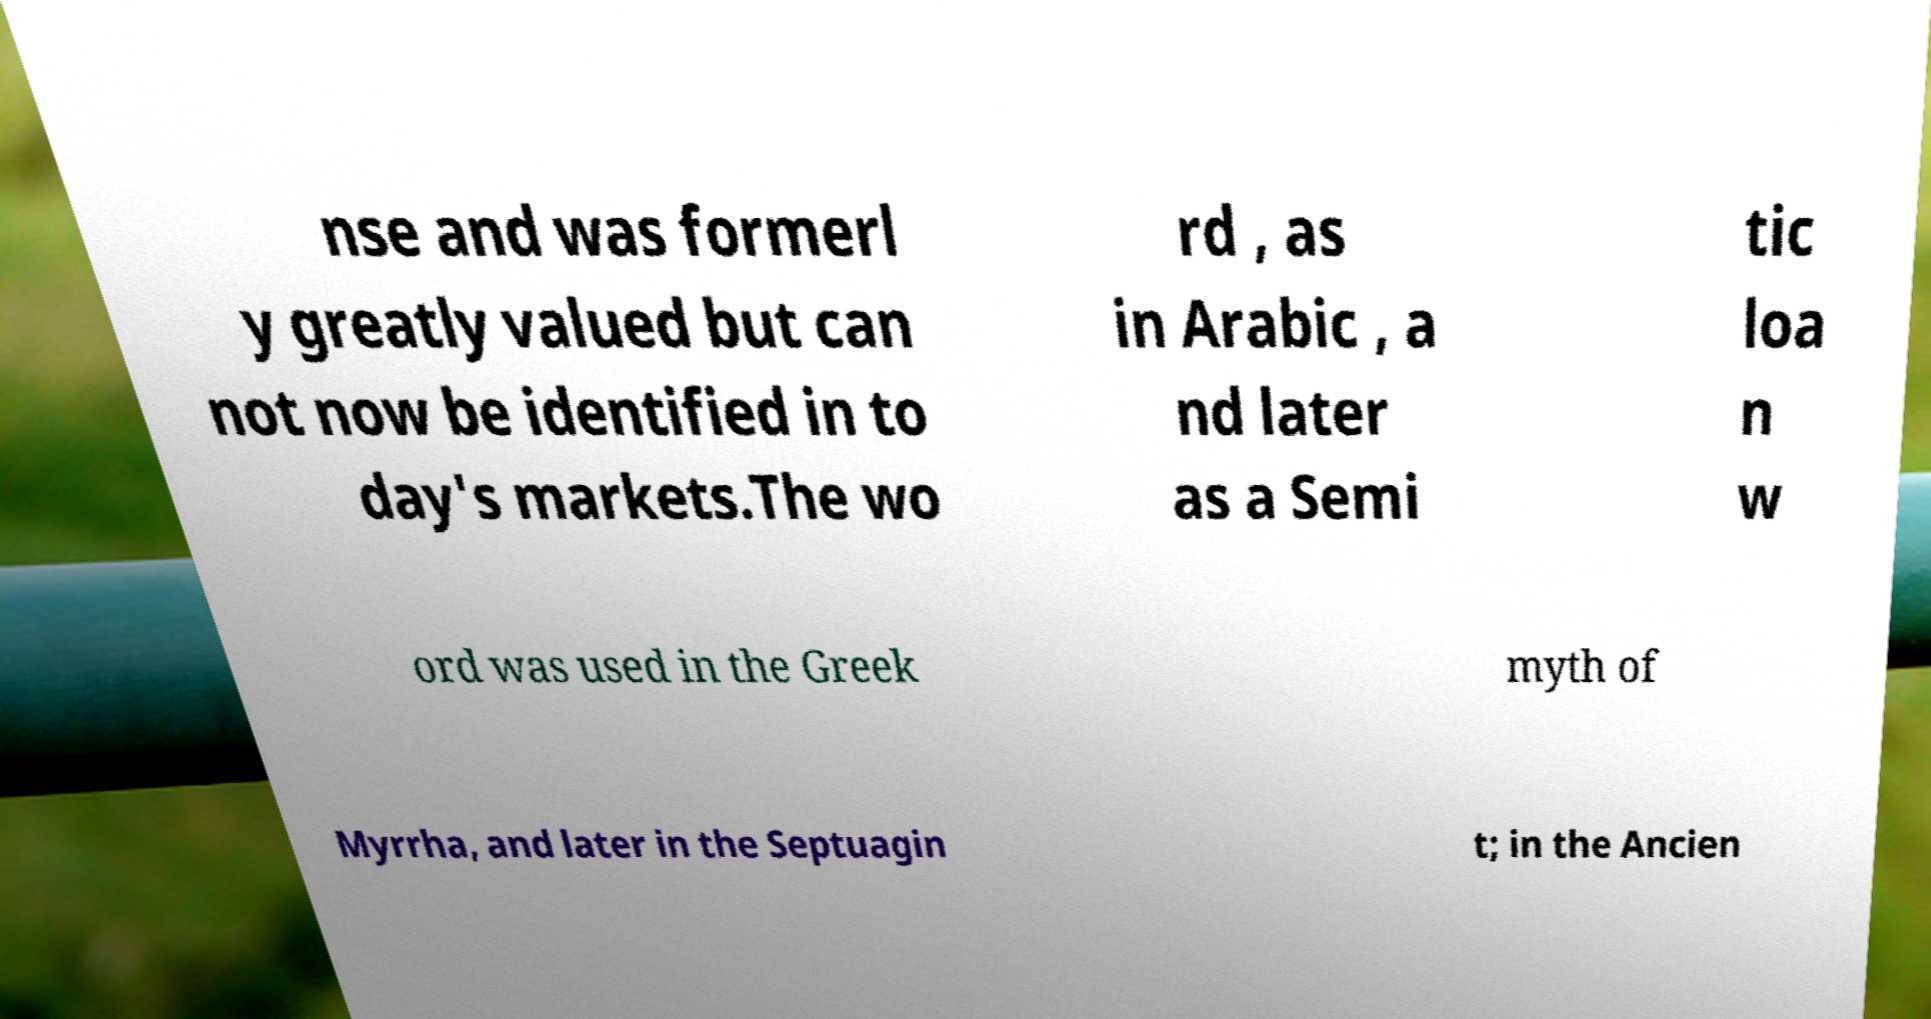Can you accurately transcribe the text from the provided image for me? nse and was formerl y greatly valued but can not now be identified in to day's markets.The wo rd , as in Arabic , a nd later as a Semi tic loa n w ord was used in the Greek myth of Myrrha, and later in the Septuagin t; in the Ancien 